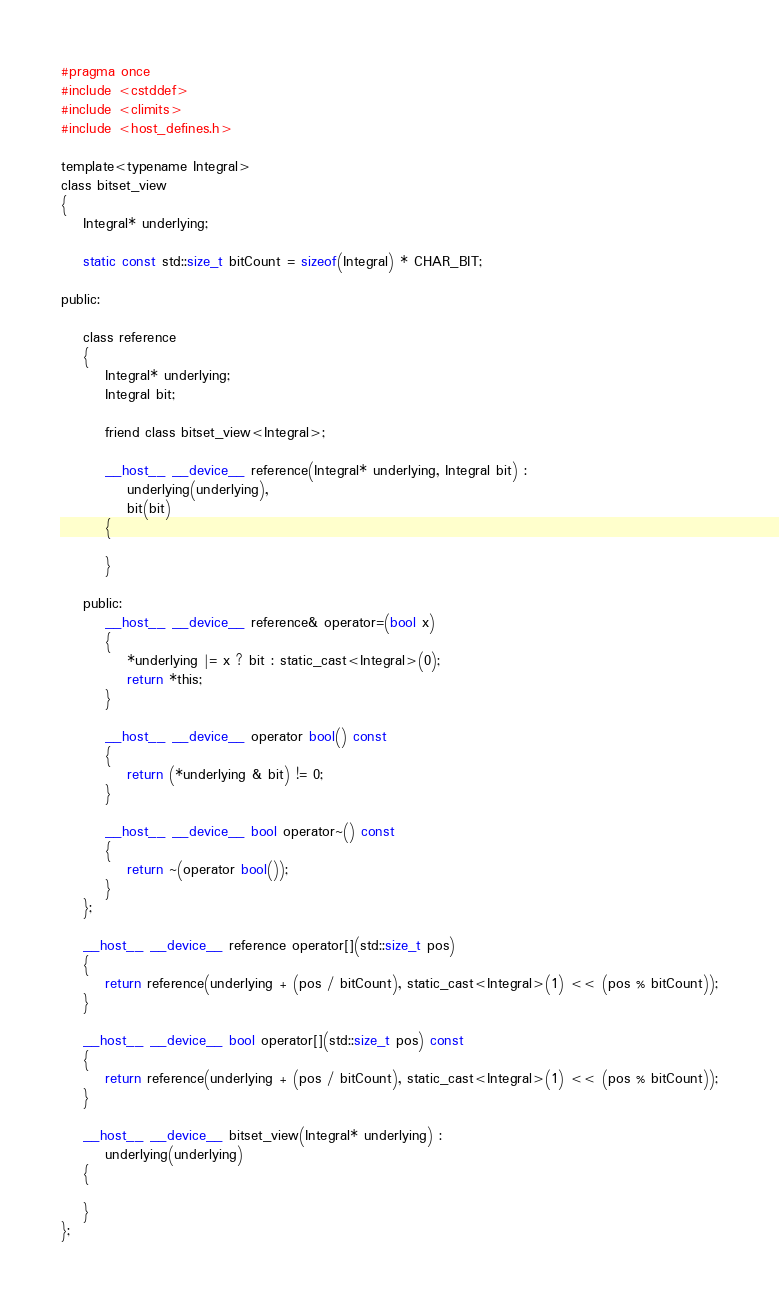Convert code to text. <code><loc_0><loc_0><loc_500><loc_500><_Cuda_>#pragma once
#include <cstddef>
#include <climits>
#include <host_defines.h>

template<typename Integral>
class bitset_view
{
	Integral* underlying;

	static const std::size_t bitCount = sizeof(Integral) * CHAR_BIT;

public:

	class reference
	{
		Integral* underlying;
		Integral bit;

		friend class bitset_view<Integral>;

		__host__ __device__ reference(Integral* underlying, Integral bit) :
			underlying(underlying),
			bit(bit)
		{

		}

	public:
		__host__ __device__ reference& operator=(bool x)
		{
			*underlying |= x ? bit : static_cast<Integral>(0);
			return *this;
		}

		__host__ __device__ operator bool() const
		{
			return (*underlying & bit) != 0;
		}

		__host__ __device__ bool operator~() const
		{
			return ~(operator bool());
		}
	};

	__host__ __device__ reference operator[](std::size_t pos)
	{
		return reference(underlying + (pos / bitCount), static_cast<Integral>(1) << (pos % bitCount));
	}

	__host__ __device__ bool operator[](std::size_t pos) const
	{
		return reference(underlying + (pos / bitCount), static_cast<Integral>(1) << (pos % bitCount));
	}

	__host__ __device__ bitset_view(Integral* underlying) :
		underlying(underlying)
	{

	}
};
</code> 